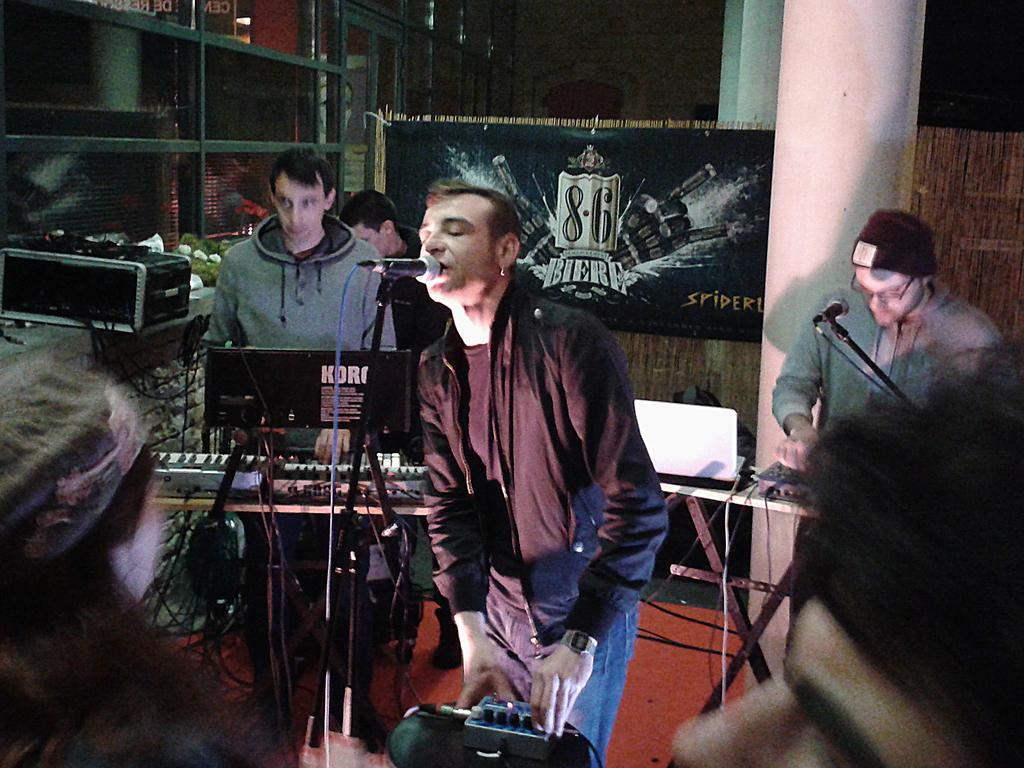How many people are in the image? There are people in the image, but the exact number is not specified. What are some people doing in the image? Some people are holding objects, and a person is singing in front of a microphone. What can be seen in the background of the image? In the background, there is a banner, pillars, doors, and rods. What type of education is being offered at the shop in the image? There is no shop or education being offered in the image; it features people, a singer, and various background elements. How does the nerve system of the person singing in the image function? There is no information about the nerve system of the person singing in the image, as the focus is on their actions and the surrounding environment. 